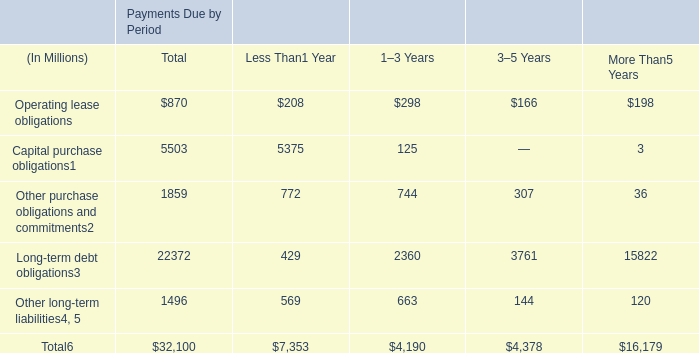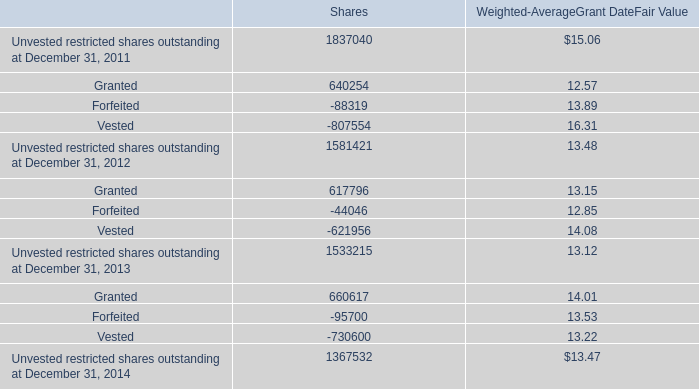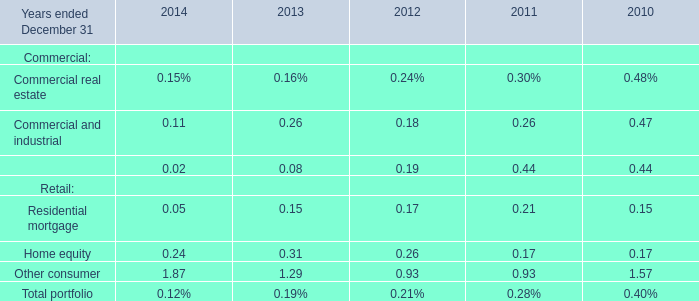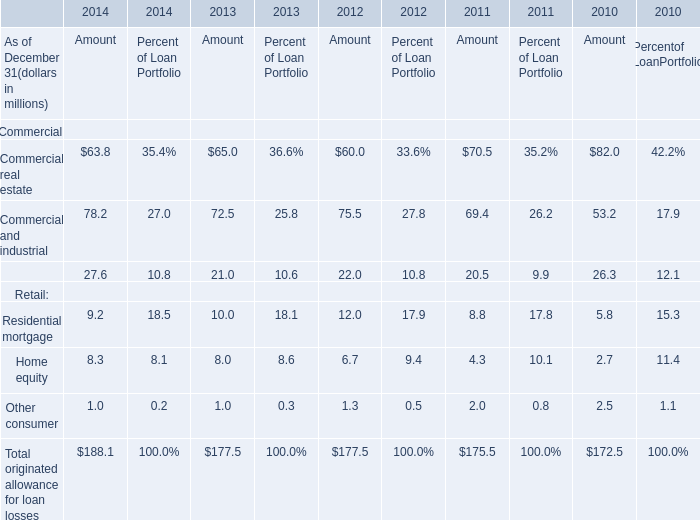What is the sum of the Equipment financing in the years where Commercial and industrial is greater than 0? 
Computations: ((((0.02 + 0.08) + 0.19) + 0.44) + 0.44)
Answer: 1.17. 